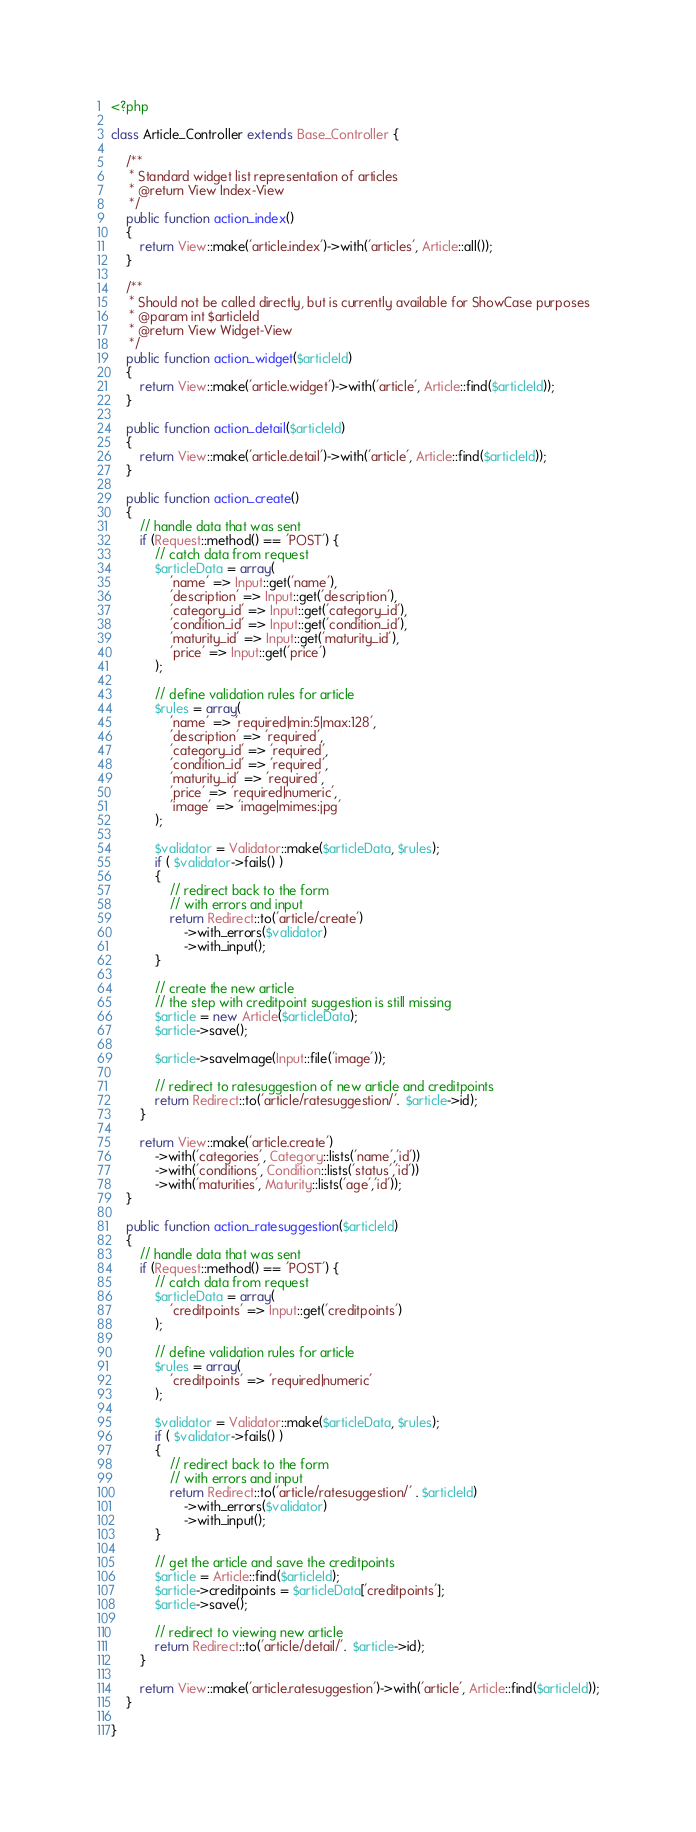Convert code to text. <code><loc_0><loc_0><loc_500><loc_500><_PHP_><?php

class Article_Controller extends Base_Controller {

    /**
     * Standard widget list representation of articles
     * @return View Index-View
     */
	public function action_index()
	{
		return View::make('article.index')->with('articles', Article::all());
	}

    /**
     * Should not be called directly, but is currently available for ShowCase purposes
     * @param int $articleId
     * @return View Widget-View
     */
	public function action_widget($articleId)
	{
		return View::make('article.widget')->with('article', Article::find($articleId));
	}

	public function action_detail($articleId)
	{
		return View::make('article.detail')->with('article', Article::find($articleId));
	}

	public function action_create()
	{
        // handle data that was sent
        if (Request::method() == 'POST') {
            // catch data from request
            $articleData = array(
                'name' => Input::get('name'),
                'description' => Input::get('description'),
                'category_id' => Input::get('category_id'),
                'condition_id' => Input::get('condition_id'),
                'maturity_id' => Input::get('maturity_id'),
                'price' => Input::get('price')
            );

            // define validation rules for article
            $rules = array(
                'name' => 'required|min:5|max:128',
                'description' => 'required',
                'category_id' => 'required',
                'condition_id' => 'required',
                'maturity_id' => 'required',
                'price' => 'required|numeric',
                'image' => 'image|mimes:jpg'
            );

            $validator = Validator::make($articleData, $rules);
            if ( $validator->fails() )
            {
                // redirect back to the form
                // with errors and input
                return Redirect::to('article/create')
                    ->with_errors($validator)
                    ->with_input();
            }

            // create the new article
            // the step with creditpoint suggestion is still missing
            $article = new Article($articleData);
            $article->save();

            $article->saveImage(Input::file('image'));

            // redirect to ratesuggestion of new article and creditpoints
            return Redirect::to('article/ratesuggestion/'.  $article->id);
        }

		return View::make('article.create')
            ->with('categories', Category::lists('name','id'))
            ->with('conditions', Condition::lists('status','id'))
            ->with('maturities', Maturity::lists('age','id'));
	}

	public function action_ratesuggestion($articleId)
	{
        // handle data that was sent
        if (Request::method() == 'POST') {
            // catch data from request
            $articleData = array(
                'creditpoints' => Input::get('creditpoints')
            );

            // define validation rules for article
            $rules = array(
                'creditpoints' => 'required|numeric'
            );

            $validator = Validator::make($articleData, $rules);
            if ( $validator->fails() )
            {
                // redirect back to the form
                // with errors and input
                return Redirect::to('article/ratesuggestion/' . $articleId)
                    ->with_errors($validator)
                    ->with_input();
            }

            // get the article and save the creditpoints
            $article = Article::find($articleId);
            $article->creditpoints = $articleData['creditpoints'];
            $article->save();

            // redirect to viewing new article
            return Redirect::to('article/detail/'.  $article->id);
        }

		return View::make('article.ratesuggestion')->with('article', Article::find($articleId));
	}

}
</code> 